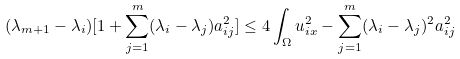Convert formula to latex. <formula><loc_0><loc_0><loc_500><loc_500>( \lambda _ { m + 1 } - \lambda _ { i } ) [ 1 + \sum ^ { m } _ { j = 1 } ( \lambda _ { i } - \lambda _ { j } ) a ^ { 2 } _ { i j } ] \leq 4 \int _ { \Omega } u ^ { 2 } _ { i x } - \sum ^ { m } _ { j = 1 } ( \lambda _ { i } - \lambda _ { j } ) ^ { 2 } a ^ { 2 } _ { i j }</formula> 